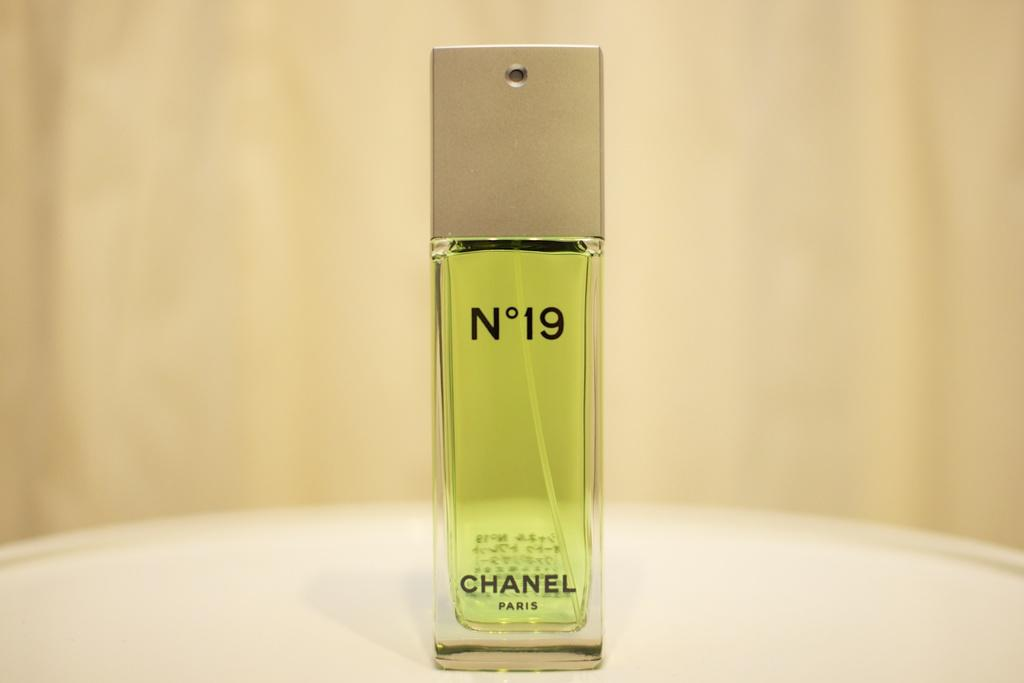<image>
Summarize the visual content of the image. A tall spritzer bottle of Chanel No 19 perfume. 